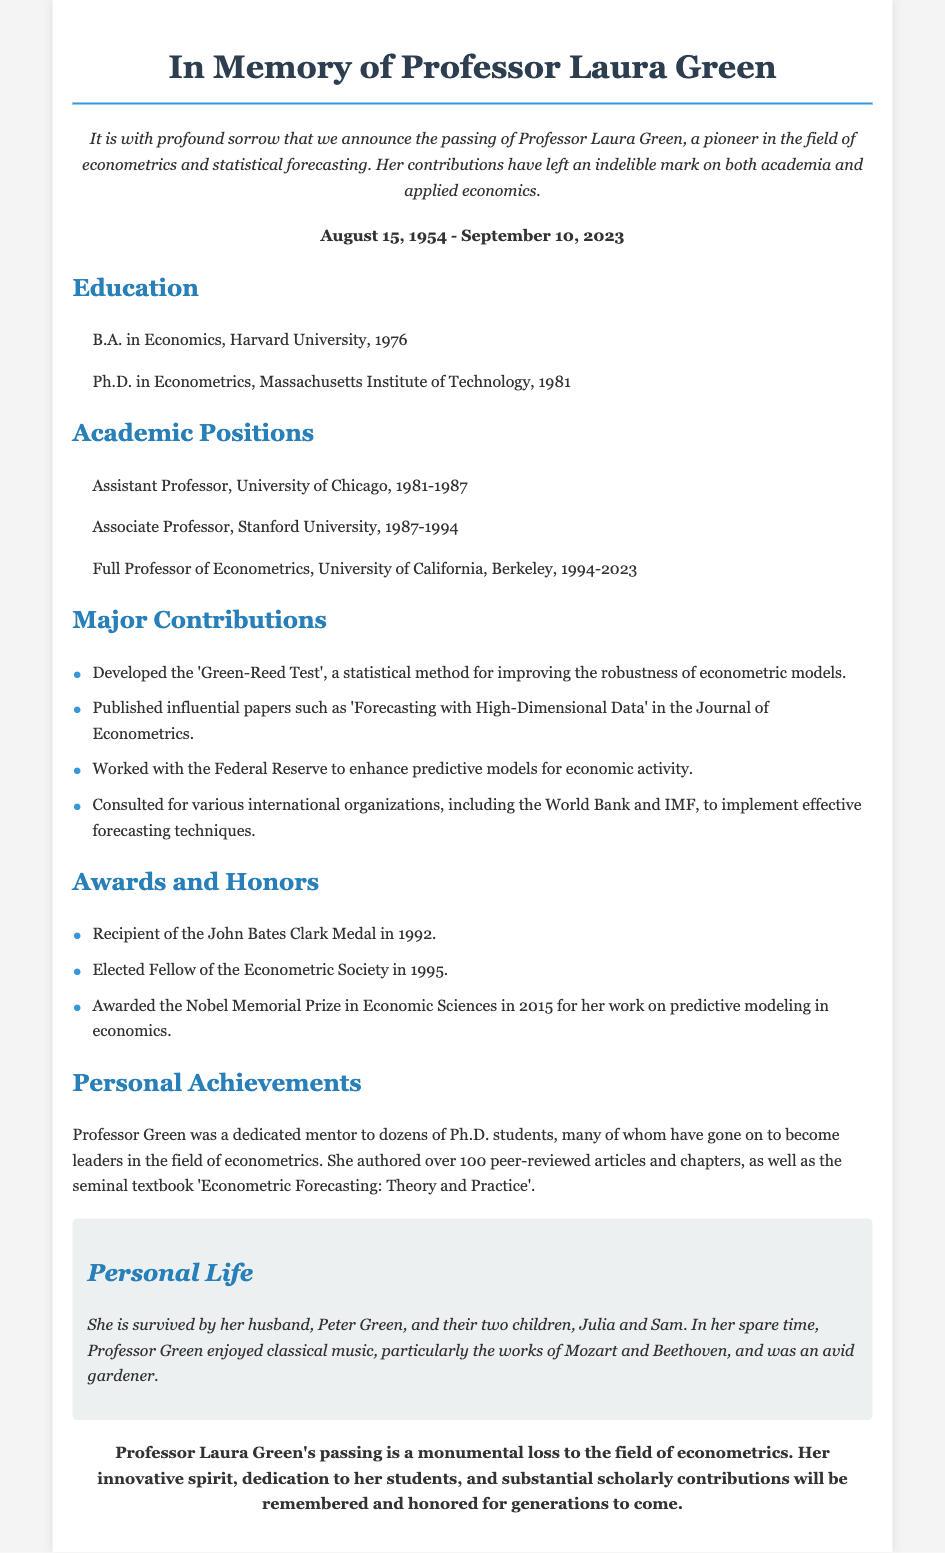What were the life dates of Professor Laura Green? The dates are listed under "life-dates" in the document.
Answer: August 15, 1954 - September 10, 2023 What prestigious award did Professor Green receive in 2015? This information can be found under "Awards and Honors" in the document.
Answer: Nobel Memorial Prize in Economic Sciences What academic title did Laura Green hold at Berkeley? The title is mentioned under "Academic Positions".
Answer: Full Professor of Econometrics Which university did Professor Green attend for her Ph.D.? The educational background is detailed in the "Education" section.
Answer: Massachusetts Institute of Technology What statistical method did Professor Green develop? This is detailed under "Major Contributions" in the document.
Answer: Green-Reed Test Who survived Professor Green? This information is located in the "Personal Life" section of the document.
Answer: Peter Green and their two children, Julia and Sam What was the title of Laura Green's seminal textbook? The title can be found in the "Personal Achievements" section.
Answer: Econometric Forecasting: Theory and Practice Which international organizations did she consult for? This is mentioned in the "Major Contributions" section.
Answer: World Bank and IMF What is a notable aspect of Professor Green's mentorship? This is highlighted in the "Personal Achievements" section of the obituary.
Answer: Mentored dozens of Ph.D. students 